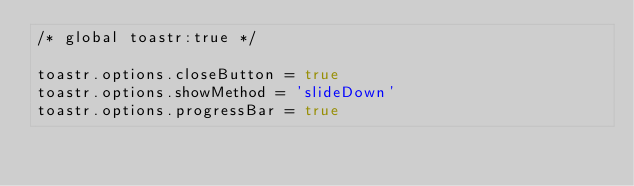<code> <loc_0><loc_0><loc_500><loc_500><_JavaScript_>/* global toastr:true */

toastr.options.closeButton = true
toastr.options.showMethod = 'slideDown'
toastr.options.progressBar = true
</code> 